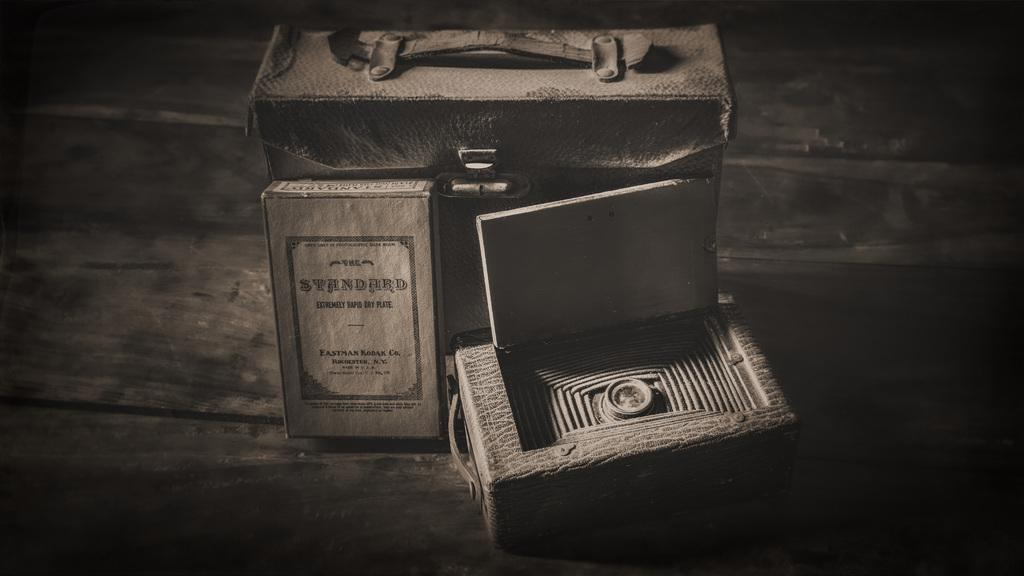What object is present in the image that can be used for carrying items? There is a bag in the image that can be used for carrying items. How many boxes are visible in the image? There are two boxes in the image. Where are the bag and boxes located in the image? The bag and boxes are placed on a table. How does the bag increase the comfort of the boxes in the image? The bag does not increase the comfort of the boxes in the image, as there is no interaction or relationship between the bag and the boxes that would suggest such an effect. 